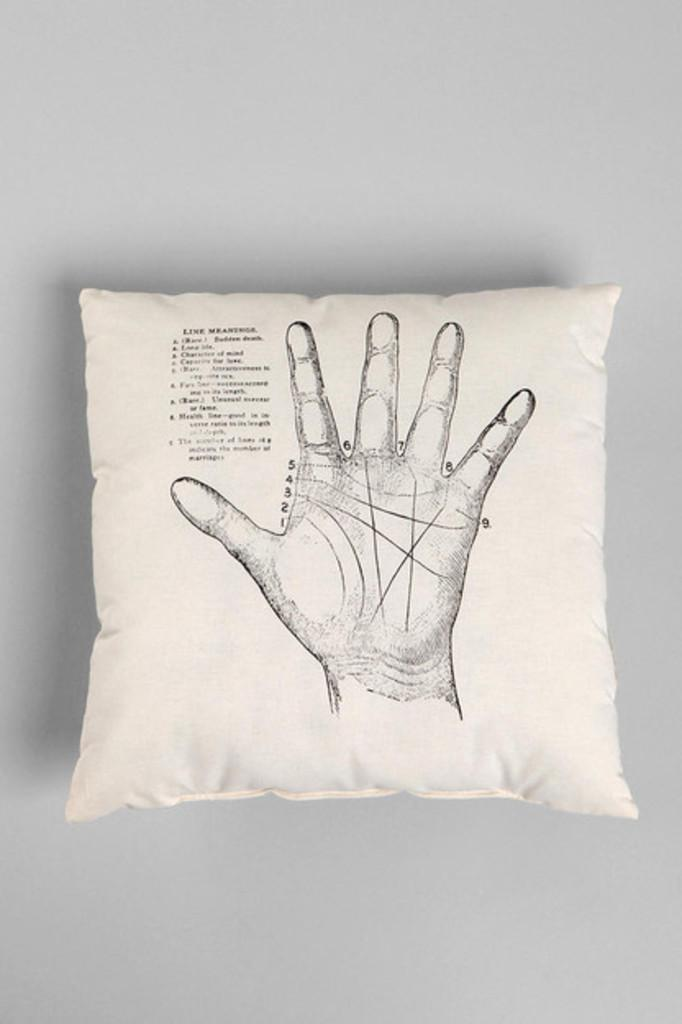What object can be seen in the image? There is a pillow in the image. What is unique about the design of the pillow? The pillow has a hand and text printed on it. What color is the background of the image? The background of the image is white. What color is the pillow itself? The pillow is white in color. Can you tell me how many kittens are sitting on the pillow in the image? There are no kittens present in the image; the pillow has a hand and text printed on it. 